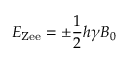<formula> <loc_0><loc_0><loc_500><loc_500>E _ { Z e e } = \pm \frac { 1 } { 2 } h \gamma B _ { 0 }</formula> 